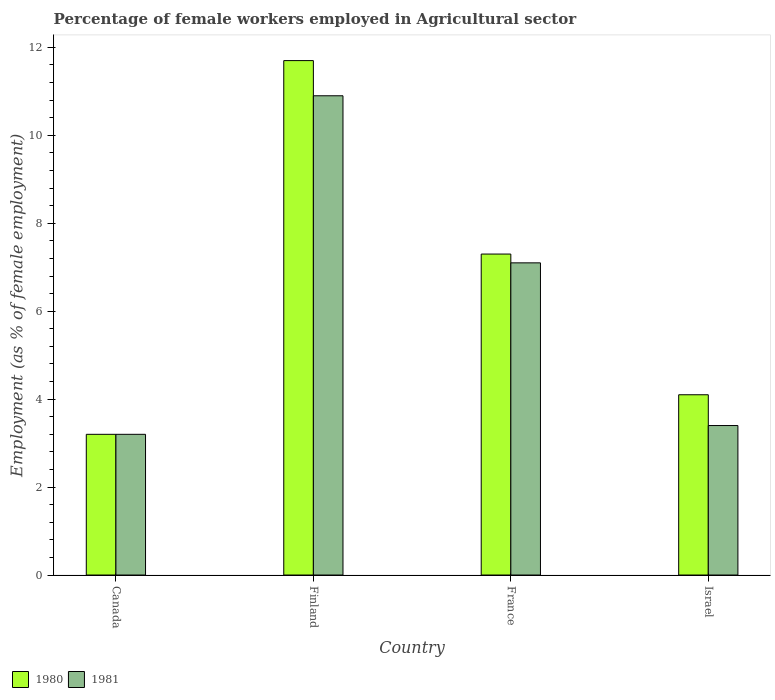How many different coloured bars are there?
Provide a succinct answer. 2. Are the number of bars per tick equal to the number of legend labels?
Offer a terse response. Yes. Are the number of bars on each tick of the X-axis equal?
Your answer should be very brief. Yes. How many bars are there on the 1st tick from the left?
Offer a very short reply. 2. In how many cases, is the number of bars for a given country not equal to the number of legend labels?
Give a very brief answer. 0. What is the percentage of females employed in Agricultural sector in 1981 in Canada?
Your answer should be very brief. 3.2. Across all countries, what is the maximum percentage of females employed in Agricultural sector in 1981?
Ensure brevity in your answer.  10.9. Across all countries, what is the minimum percentage of females employed in Agricultural sector in 1980?
Your response must be concise. 3.2. In which country was the percentage of females employed in Agricultural sector in 1981 minimum?
Provide a succinct answer. Canada. What is the total percentage of females employed in Agricultural sector in 1980 in the graph?
Your response must be concise. 26.3. What is the difference between the percentage of females employed in Agricultural sector in 1981 in France and that in Israel?
Keep it short and to the point. 3.7. What is the difference between the percentage of females employed in Agricultural sector in 1980 in France and the percentage of females employed in Agricultural sector in 1981 in Canada?
Ensure brevity in your answer.  4.1. What is the average percentage of females employed in Agricultural sector in 1980 per country?
Your response must be concise. 6.57. What is the difference between the percentage of females employed in Agricultural sector of/in 1980 and percentage of females employed in Agricultural sector of/in 1981 in France?
Offer a very short reply. 0.2. What is the ratio of the percentage of females employed in Agricultural sector in 1981 in Canada to that in Israel?
Your answer should be very brief. 0.94. Is the percentage of females employed in Agricultural sector in 1980 in Canada less than that in Finland?
Provide a succinct answer. Yes. Is the difference between the percentage of females employed in Agricultural sector in 1980 in Canada and Finland greater than the difference between the percentage of females employed in Agricultural sector in 1981 in Canada and Finland?
Your answer should be very brief. No. What is the difference between the highest and the second highest percentage of females employed in Agricultural sector in 1980?
Provide a short and direct response. 7.6. What is the difference between the highest and the lowest percentage of females employed in Agricultural sector in 1981?
Make the answer very short. 7.7. In how many countries, is the percentage of females employed in Agricultural sector in 1980 greater than the average percentage of females employed in Agricultural sector in 1980 taken over all countries?
Offer a very short reply. 2. Is the sum of the percentage of females employed in Agricultural sector in 1980 in Canada and Finland greater than the maximum percentage of females employed in Agricultural sector in 1981 across all countries?
Your answer should be very brief. Yes. What does the 1st bar from the left in Israel represents?
Ensure brevity in your answer.  1980. What does the 2nd bar from the right in Israel represents?
Provide a short and direct response. 1980. How many bars are there?
Offer a very short reply. 8. Are all the bars in the graph horizontal?
Provide a succinct answer. No. How many countries are there in the graph?
Your answer should be very brief. 4. What is the difference between two consecutive major ticks on the Y-axis?
Offer a terse response. 2. Are the values on the major ticks of Y-axis written in scientific E-notation?
Give a very brief answer. No. Does the graph contain grids?
Your answer should be compact. No. What is the title of the graph?
Your response must be concise. Percentage of female workers employed in Agricultural sector. What is the label or title of the Y-axis?
Keep it short and to the point. Employment (as % of female employment). What is the Employment (as % of female employment) in 1980 in Canada?
Your answer should be compact. 3.2. What is the Employment (as % of female employment) in 1981 in Canada?
Your response must be concise. 3.2. What is the Employment (as % of female employment) of 1980 in Finland?
Make the answer very short. 11.7. What is the Employment (as % of female employment) of 1981 in Finland?
Your answer should be compact. 10.9. What is the Employment (as % of female employment) of 1980 in France?
Your answer should be compact. 7.3. What is the Employment (as % of female employment) of 1981 in France?
Your answer should be very brief. 7.1. What is the Employment (as % of female employment) of 1980 in Israel?
Offer a terse response. 4.1. What is the Employment (as % of female employment) of 1981 in Israel?
Ensure brevity in your answer.  3.4. Across all countries, what is the maximum Employment (as % of female employment) of 1980?
Make the answer very short. 11.7. Across all countries, what is the maximum Employment (as % of female employment) of 1981?
Ensure brevity in your answer.  10.9. Across all countries, what is the minimum Employment (as % of female employment) in 1980?
Ensure brevity in your answer.  3.2. Across all countries, what is the minimum Employment (as % of female employment) of 1981?
Provide a short and direct response. 3.2. What is the total Employment (as % of female employment) of 1980 in the graph?
Your response must be concise. 26.3. What is the total Employment (as % of female employment) in 1981 in the graph?
Keep it short and to the point. 24.6. What is the difference between the Employment (as % of female employment) of 1980 in Canada and that in Finland?
Provide a succinct answer. -8.5. What is the difference between the Employment (as % of female employment) of 1981 in Canada and that in Finland?
Give a very brief answer. -7.7. What is the difference between the Employment (as % of female employment) of 1980 in Canada and that in Israel?
Keep it short and to the point. -0.9. What is the difference between the Employment (as % of female employment) of 1981 in Finland and that in France?
Offer a terse response. 3.8. What is the difference between the Employment (as % of female employment) of 1980 in Canada and the Employment (as % of female employment) of 1981 in France?
Offer a terse response. -3.9. What is the difference between the Employment (as % of female employment) of 1980 in Canada and the Employment (as % of female employment) of 1981 in Israel?
Give a very brief answer. -0.2. What is the difference between the Employment (as % of female employment) in 1980 in Finland and the Employment (as % of female employment) in 1981 in Israel?
Your answer should be very brief. 8.3. What is the average Employment (as % of female employment) in 1980 per country?
Offer a terse response. 6.58. What is the average Employment (as % of female employment) of 1981 per country?
Offer a very short reply. 6.15. What is the difference between the Employment (as % of female employment) of 1980 and Employment (as % of female employment) of 1981 in Canada?
Provide a succinct answer. 0. What is the difference between the Employment (as % of female employment) in 1980 and Employment (as % of female employment) in 1981 in Finland?
Offer a very short reply. 0.8. What is the difference between the Employment (as % of female employment) of 1980 and Employment (as % of female employment) of 1981 in France?
Keep it short and to the point. 0.2. What is the difference between the Employment (as % of female employment) of 1980 and Employment (as % of female employment) of 1981 in Israel?
Give a very brief answer. 0.7. What is the ratio of the Employment (as % of female employment) of 1980 in Canada to that in Finland?
Your response must be concise. 0.27. What is the ratio of the Employment (as % of female employment) in 1981 in Canada to that in Finland?
Ensure brevity in your answer.  0.29. What is the ratio of the Employment (as % of female employment) of 1980 in Canada to that in France?
Ensure brevity in your answer.  0.44. What is the ratio of the Employment (as % of female employment) in 1981 in Canada to that in France?
Offer a terse response. 0.45. What is the ratio of the Employment (as % of female employment) of 1980 in Canada to that in Israel?
Offer a very short reply. 0.78. What is the ratio of the Employment (as % of female employment) in 1981 in Canada to that in Israel?
Your answer should be very brief. 0.94. What is the ratio of the Employment (as % of female employment) of 1980 in Finland to that in France?
Ensure brevity in your answer.  1.6. What is the ratio of the Employment (as % of female employment) in 1981 in Finland to that in France?
Your response must be concise. 1.54. What is the ratio of the Employment (as % of female employment) in 1980 in Finland to that in Israel?
Give a very brief answer. 2.85. What is the ratio of the Employment (as % of female employment) of 1981 in Finland to that in Israel?
Keep it short and to the point. 3.21. What is the ratio of the Employment (as % of female employment) of 1980 in France to that in Israel?
Keep it short and to the point. 1.78. What is the ratio of the Employment (as % of female employment) in 1981 in France to that in Israel?
Make the answer very short. 2.09. What is the difference between the highest and the second highest Employment (as % of female employment) of 1981?
Your response must be concise. 3.8. 